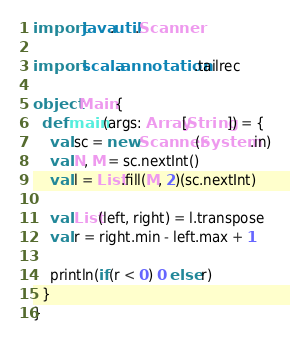<code> <loc_0><loc_0><loc_500><loc_500><_Scala_>import java.util.Scanner

import scala.annotation.tailrec

object Main {
  def main(args: Array[String]) = {
    val sc = new Scanner(System.in)
    val N, M = sc.nextInt()
    val l = List.fill(M, 2)(sc.nextInt)

    val List(left, right) = l.transpose
    val r = right.min - left.max + 1

    println(if(r < 0) 0 else r)
  }
}</code> 